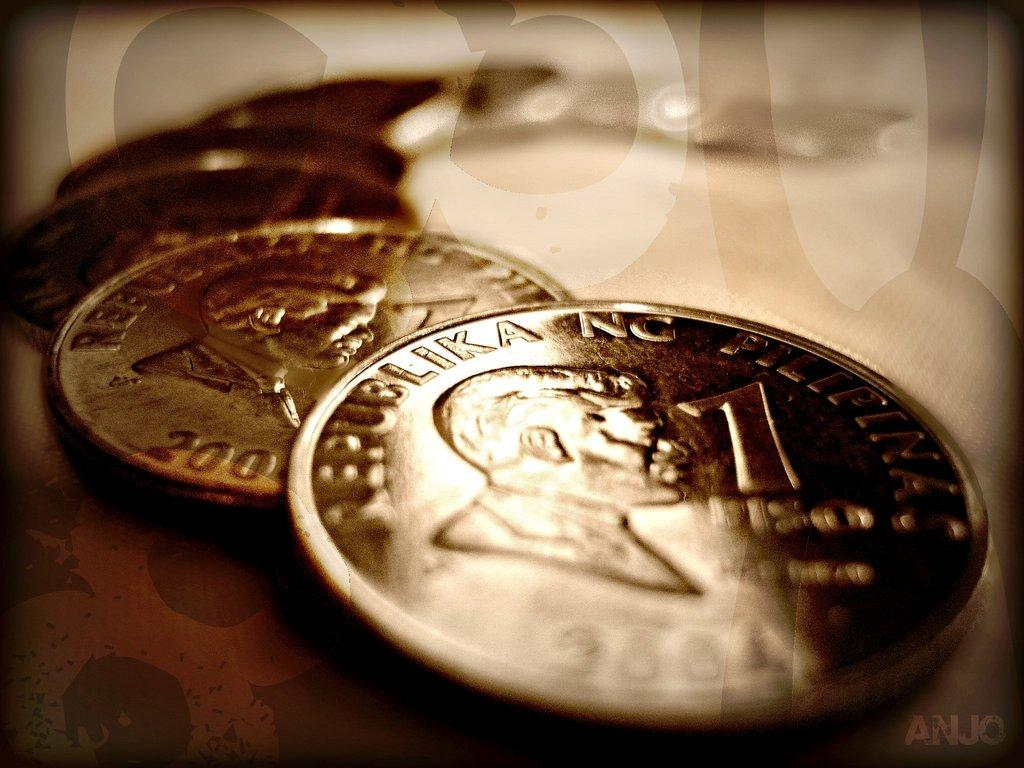Provide a one-sentence caption for the provided image. Several one cent coins of Republika NC from 2001 overlapping each other. 